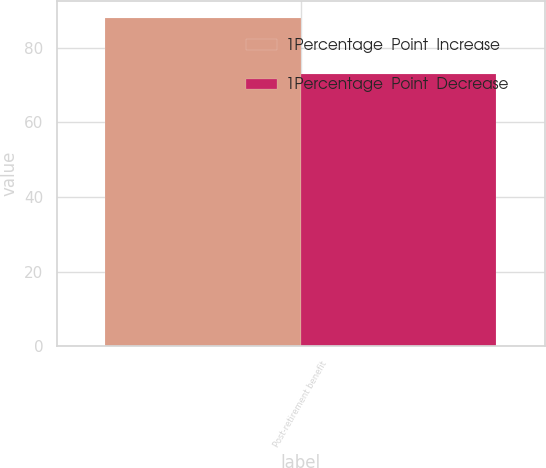<chart> <loc_0><loc_0><loc_500><loc_500><stacked_bar_chart><ecel><fcel>Post-retirement benefit<nl><fcel>1Percentage  Point  Increase<fcel>88<nl><fcel>1Percentage  Point  Decrease<fcel>73<nl></chart> 